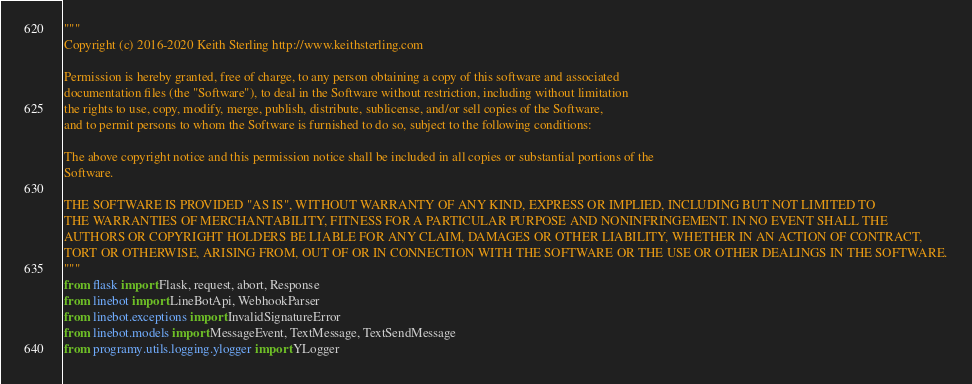<code> <loc_0><loc_0><loc_500><loc_500><_Python_>"""
Copyright (c) 2016-2020 Keith Sterling http://www.keithsterling.com

Permission is hereby granted, free of charge, to any person obtaining a copy of this software and associated
documentation files (the "Software"), to deal in the Software without restriction, including without limitation
the rights to use, copy, modify, merge, publish, distribute, sublicense, and/or sell copies of the Software,
and to permit persons to whom the Software is furnished to do so, subject to the following conditions:

The above copyright notice and this permission notice shall be included in all copies or substantial portions of the
Software.

THE SOFTWARE IS PROVIDED "AS IS", WITHOUT WARRANTY OF ANY KIND, EXPRESS OR IMPLIED, INCLUDING BUT NOT LIMITED TO
THE WARRANTIES OF MERCHANTABILITY, FITNESS FOR A PARTICULAR PURPOSE AND NONINFRINGEMENT. IN NO EVENT SHALL THE
AUTHORS OR COPYRIGHT HOLDERS BE LIABLE FOR ANY CLAIM, DAMAGES OR OTHER LIABILITY, WHETHER IN AN ACTION OF CONTRACT,
TORT OR OTHERWISE, ARISING FROM, OUT OF OR IN CONNECTION WITH THE SOFTWARE OR THE USE OR OTHER DEALINGS IN THE SOFTWARE.
"""
from flask import Flask, request, abort, Response
from linebot import LineBotApi, WebhookParser
from linebot.exceptions import InvalidSignatureError
from linebot.models import MessageEvent, TextMessage, TextSendMessage
from programy.utils.logging.ylogger import YLogger</code> 